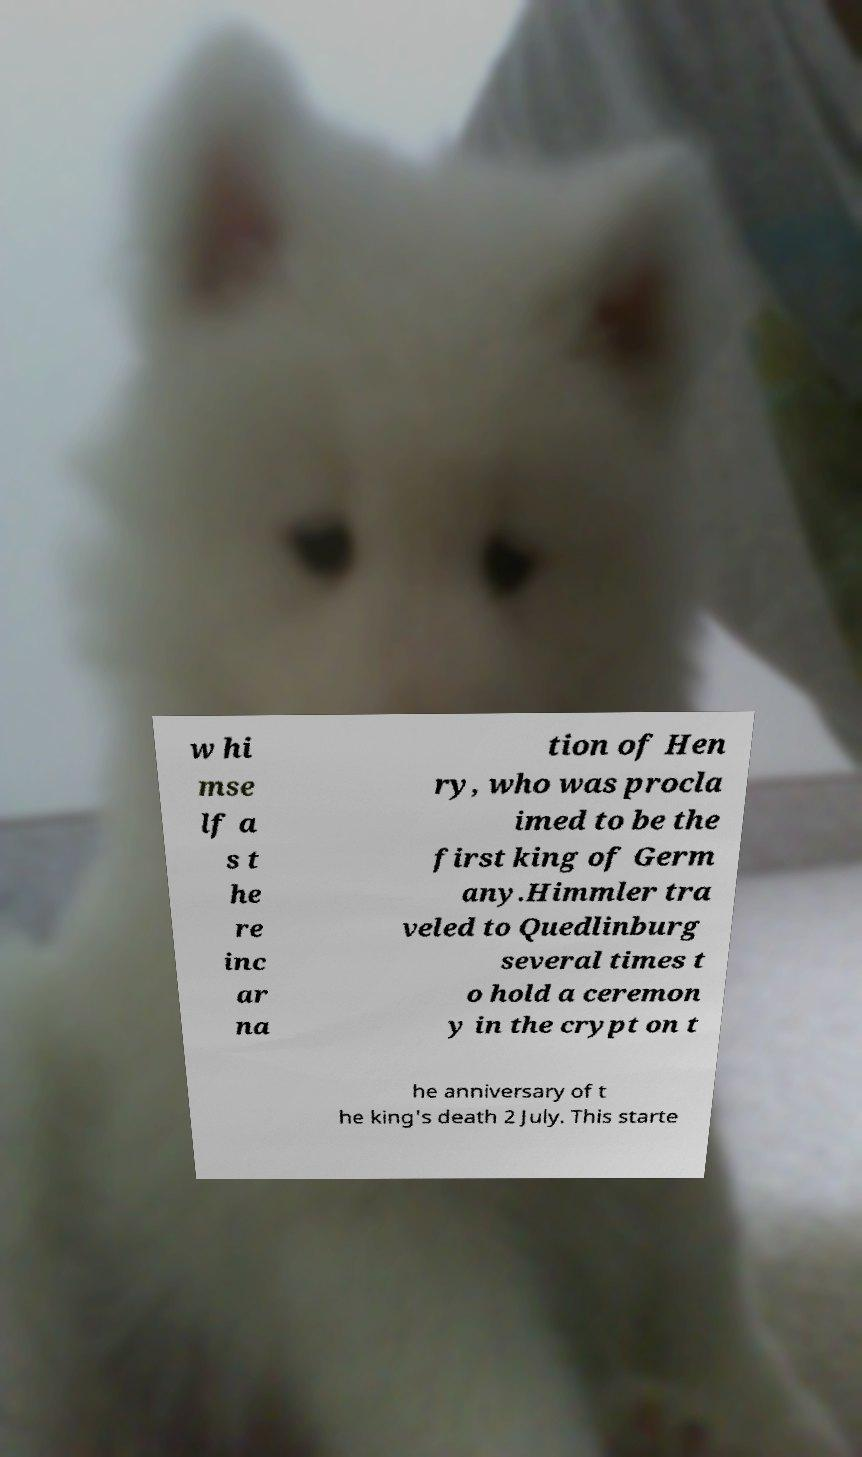Could you extract and type out the text from this image? w hi mse lf a s t he re inc ar na tion of Hen ry, who was procla imed to be the first king of Germ any.Himmler tra veled to Quedlinburg several times t o hold a ceremon y in the crypt on t he anniversary of t he king's death 2 July. This starte 